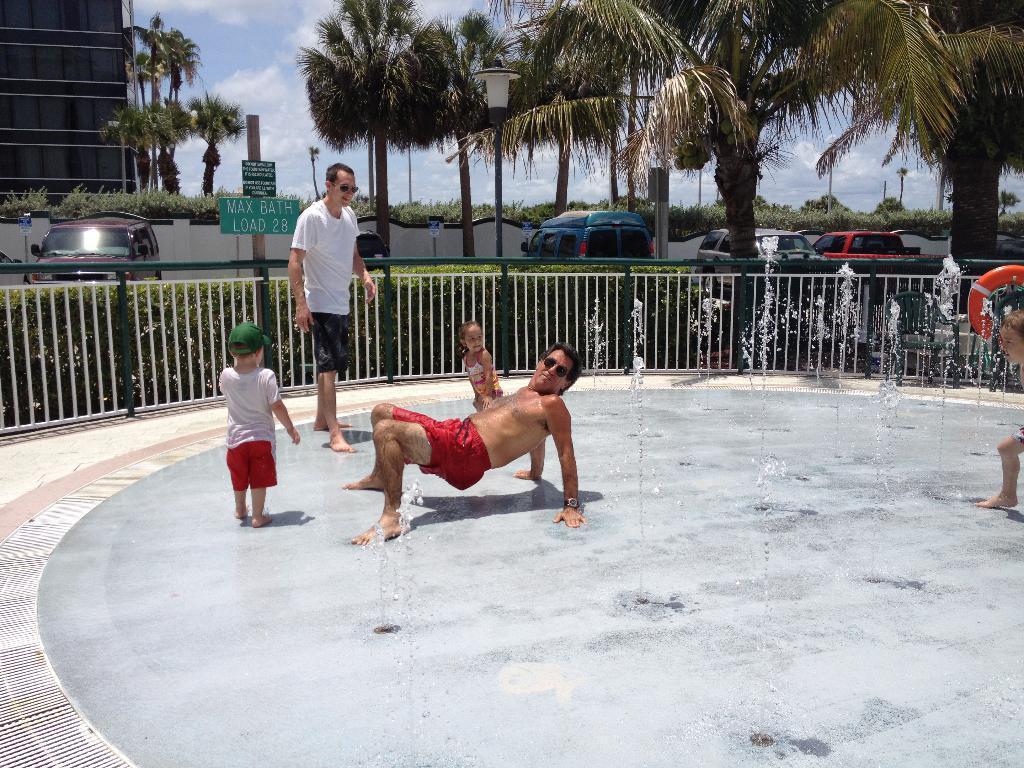Can you describe this image briefly? There are people present on the floor as we can see in the middle of this image. We can see a fence, cars, plants and trees in the background. The sky is at the top of this image. 